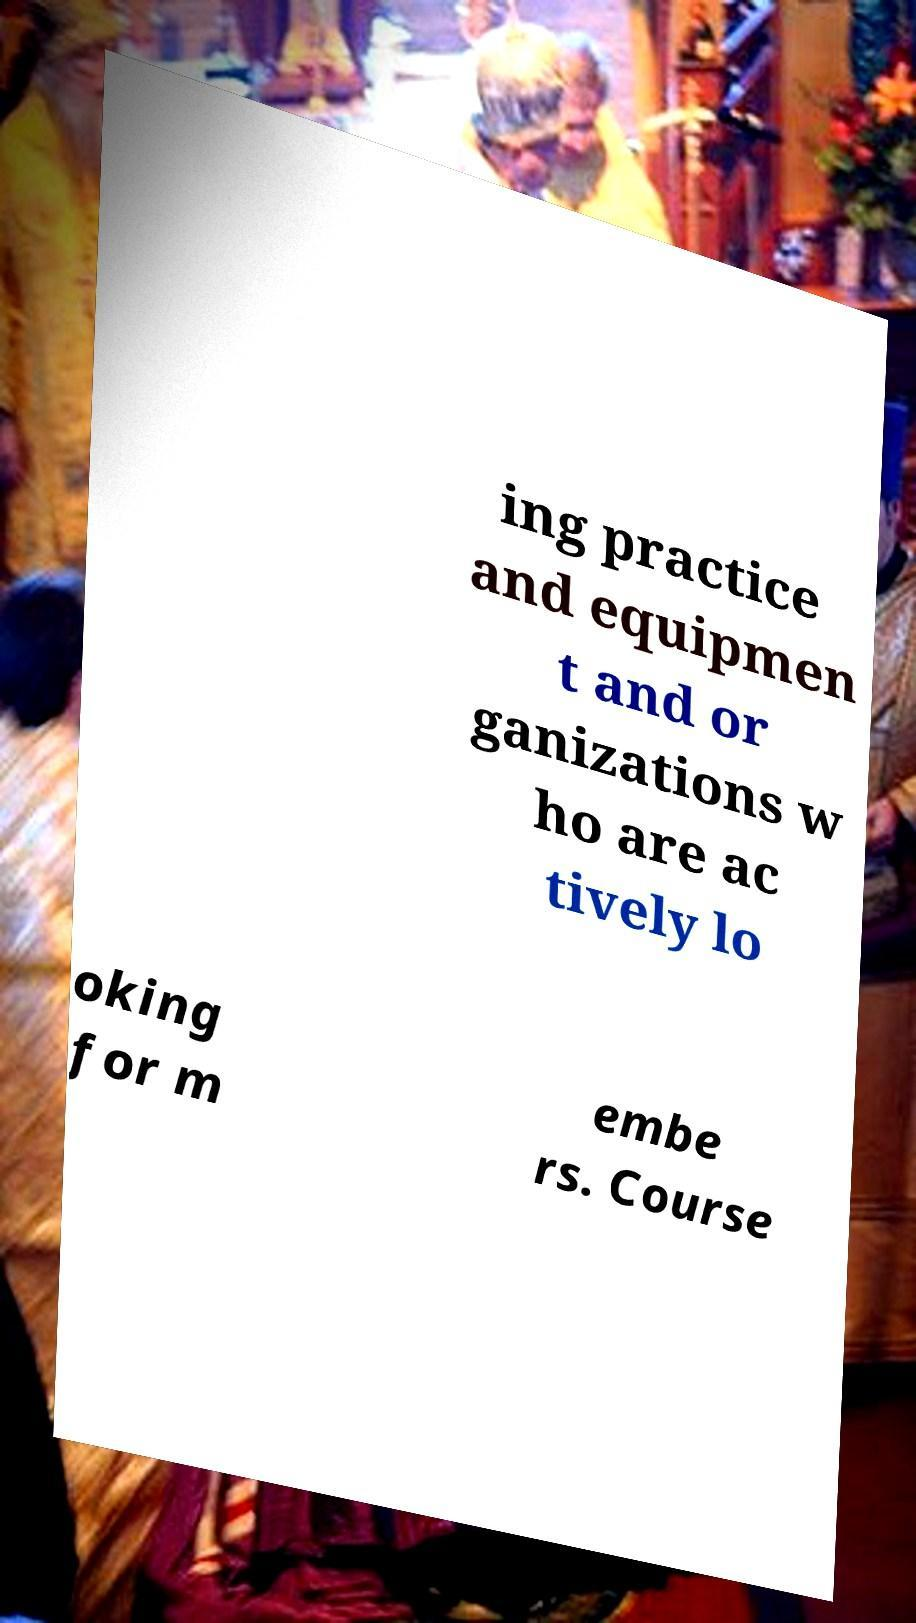Can you read and provide the text displayed in the image?This photo seems to have some interesting text. Can you extract and type it out for me? ing practice and equipmen t and or ganizations w ho are ac tively lo oking for m embe rs. Course 